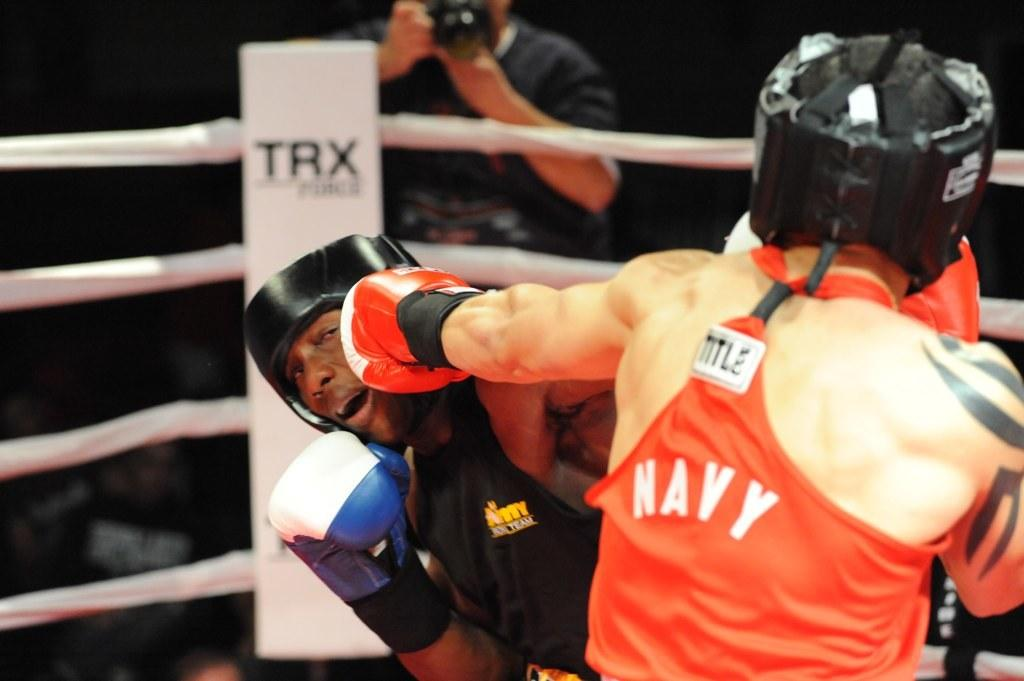What are the two people in the image doing? The two people in the image are boxing. What protective gear are the boxers wearing? The people boxing are wearing gloves. Can you describe the background of the image? In the background, there is a person holding a camera and a boxing ring. What type of locket is the boxer wearing during the match? There is no locket visible on the boxers in the image, and they are not wearing any jewelry. What role does the army play in the boxing match? There is no mention of the army or any military involvement in the image. 